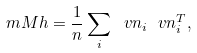<formula> <loc_0><loc_0><loc_500><loc_500>\ m M h = \frac { 1 } { n } \sum _ { i } \ v n _ { i } \ v n _ { i } ^ { T } ,</formula> 